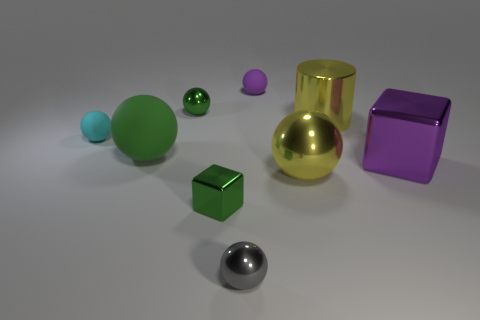Subtract 2 spheres. How many spheres are left? 4 Subtract all cyan matte spheres. How many spheres are left? 5 Subtract all green balls. How many balls are left? 4 Subtract all brown balls. Subtract all red blocks. How many balls are left? 6 Subtract all cylinders. How many objects are left? 8 Add 6 brown metallic cubes. How many brown metallic cubes exist? 6 Subtract 0 gray cylinders. How many objects are left? 9 Subtract all big purple cubes. Subtract all yellow spheres. How many objects are left? 7 Add 6 large green spheres. How many large green spheres are left? 7 